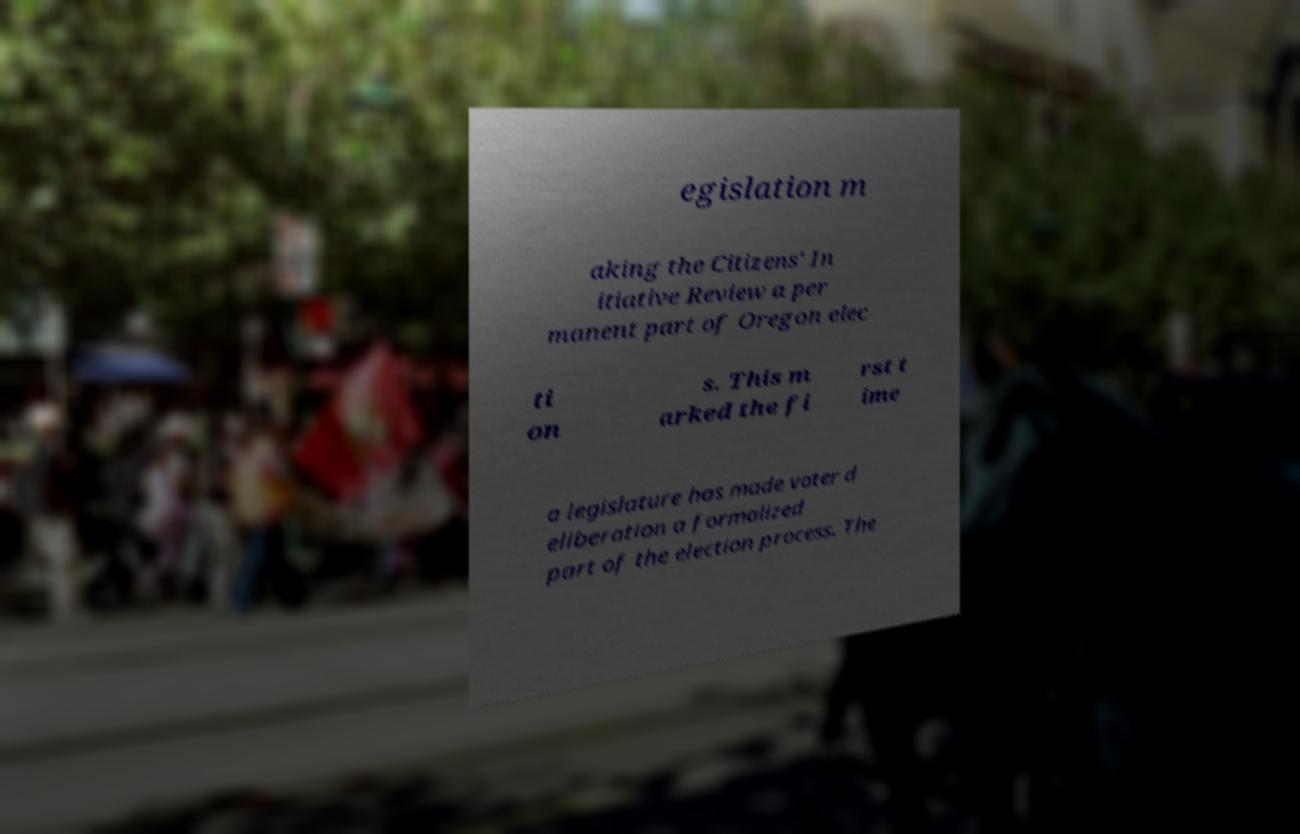Please identify and transcribe the text found in this image. egislation m aking the Citizens' In itiative Review a per manent part of Oregon elec ti on s. This m arked the fi rst t ime a legislature has made voter d eliberation a formalized part of the election process. The 